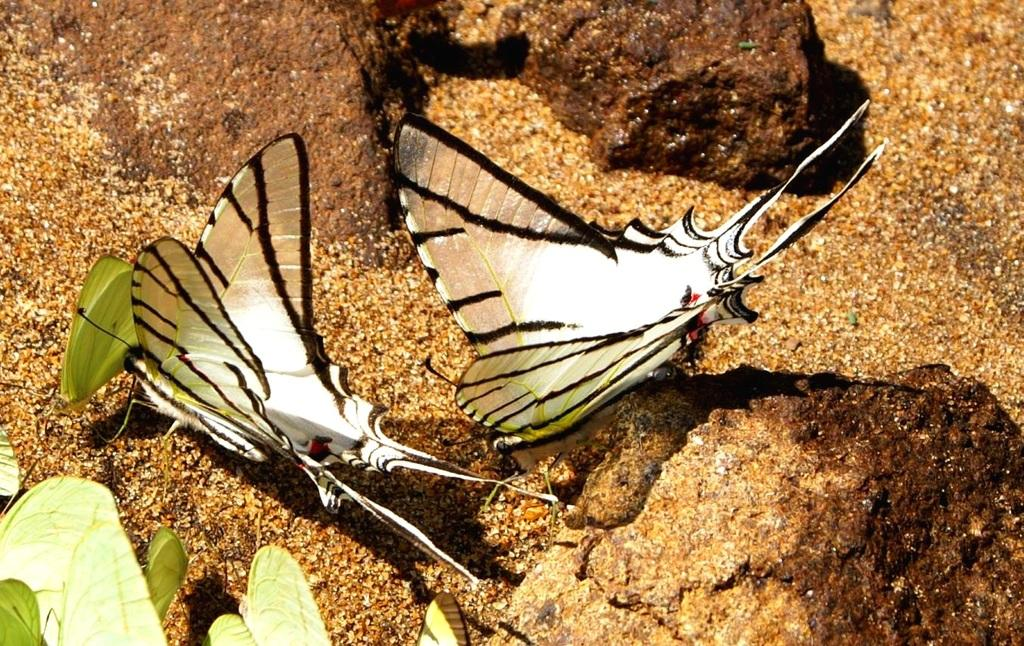What is the main subject of the image? There are two butterflies in the center of the image. What can be seen in the background of the image? There is sand in the background of the image. What is located at the bottom of the image? There are leaves at the bottom of the image. What type of floor can be seen in the image? There is no floor visible in the image; it features two butterflies, sand, and leaves. 